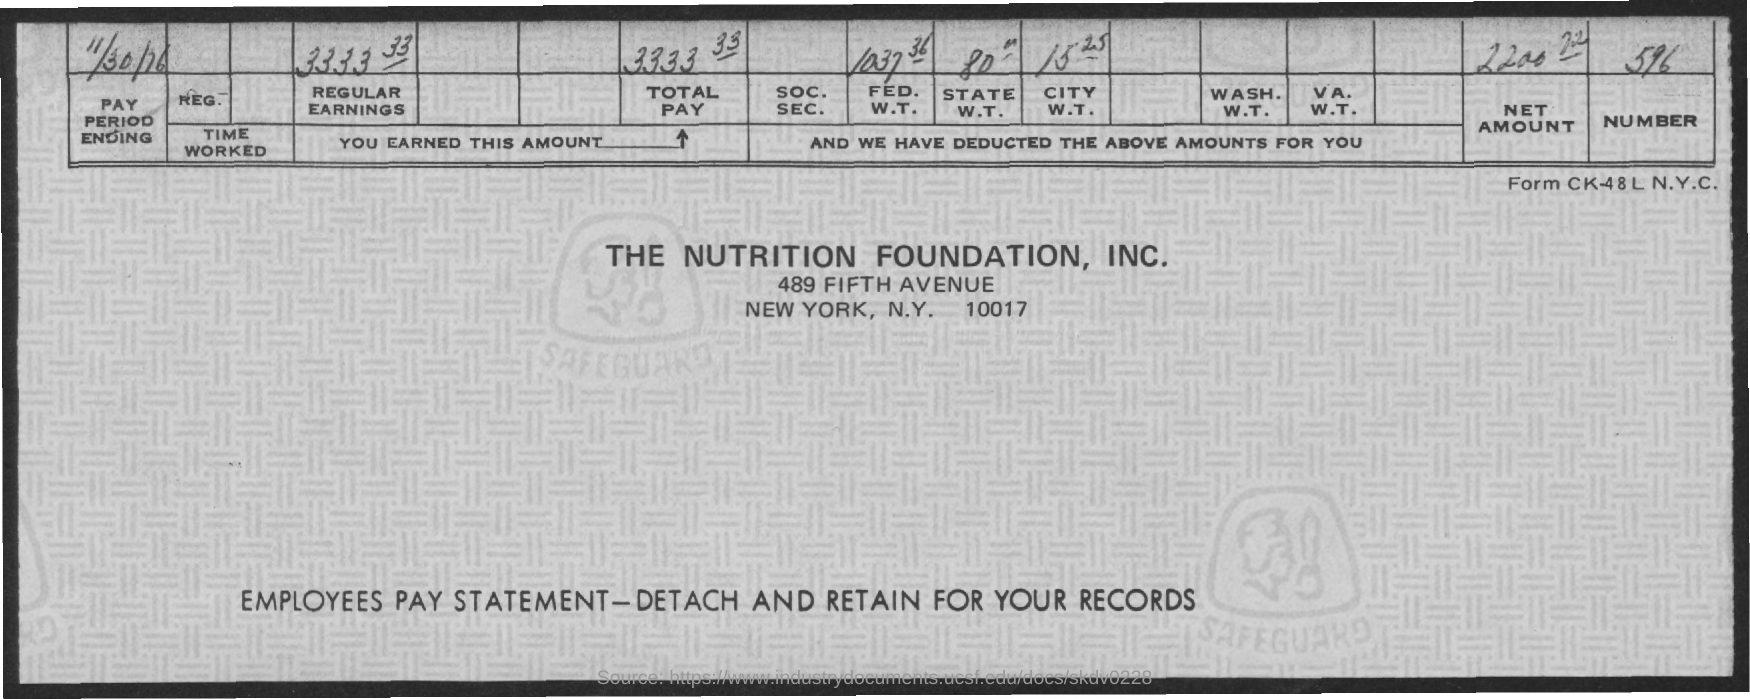Draw attention to some important aspects in this diagram. The total pay is 3333.33. The pay period ending date is November 30th, 1976. The net amount is 2200, and there are 72 cents. The question "What is the FED. W.T.? 1037 36.." is a query about the Federal Reserve System, specifically the reference number 1037 and the letters W.T. What is the City W.T.? It consists of 15 units and 25 units. 